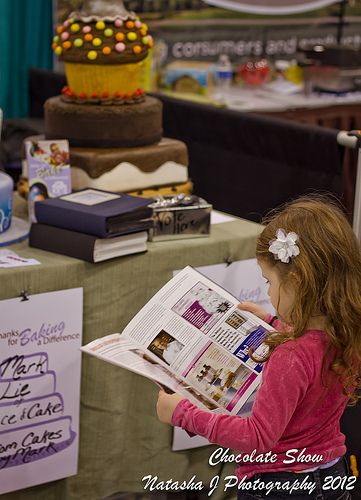Can you describe any decorations visible on the cake that's on display? The prominent cake in the image is intricately decorated with multiple layers, colorful icing, and appears to feature edible beads and a large decorative piece on top resembling a cupcake. 